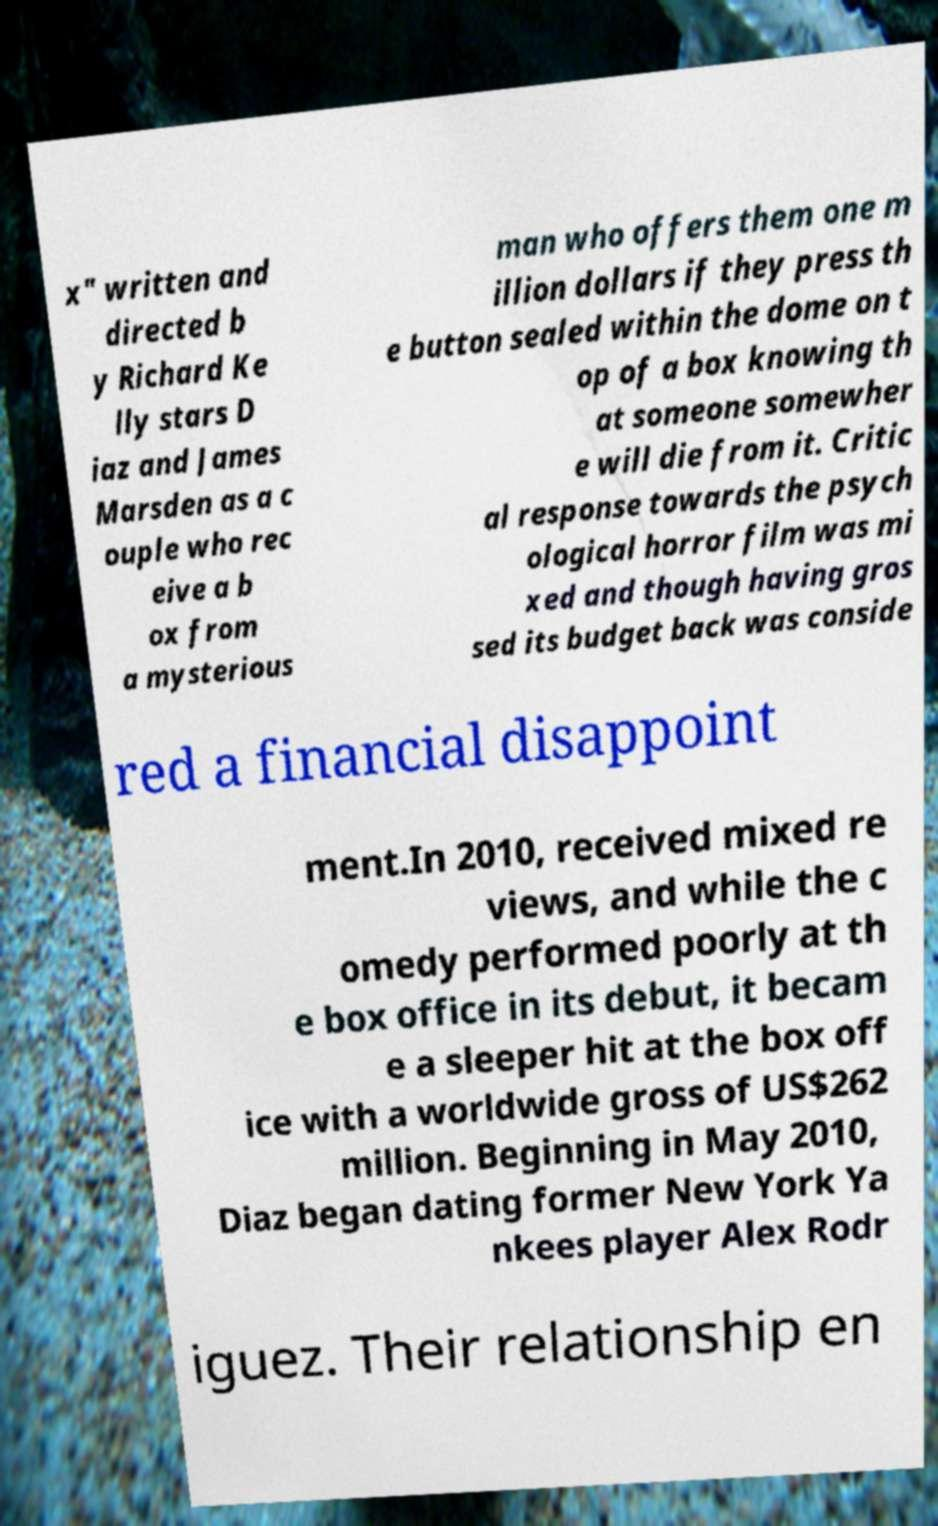For documentation purposes, I need the text within this image transcribed. Could you provide that? x" written and directed b y Richard Ke lly stars D iaz and James Marsden as a c ouple who rec eive a b ox from a mysterious man who offers them one m illion dollars if they press th e button sealed within the dome on t op of a box knowing th at someone somewher e will die from it. Critic al response towards the psych ological horror film was mi xed and though having gros sed its budget back was conside red a financial disappoint ment.In 2010, received mixed re views, and while the c omedy performed poorly at th e box office in its debut, it becam e a sleeper hit at the box off ice with a worldwide gross of US$262 million. Beginning in May 2010, Diaz began dating former New York Ya nkees player Alex Rodr iguez. Their relationship en 